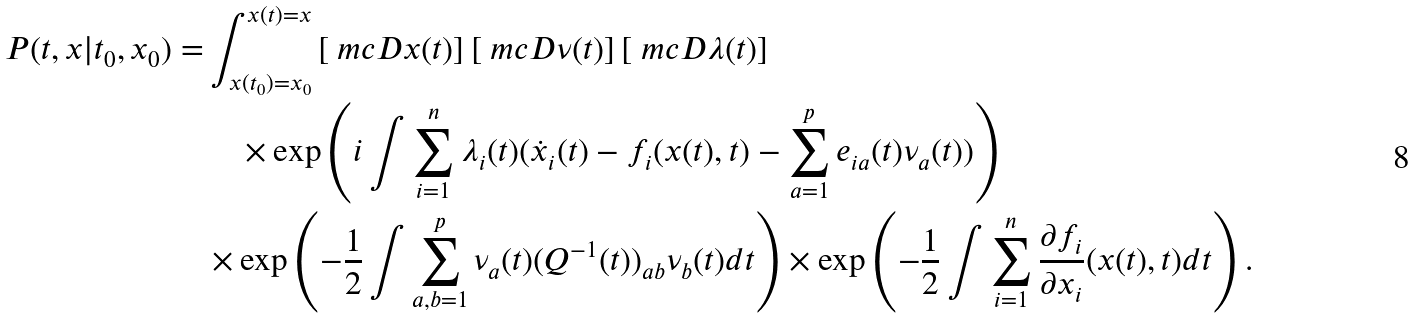<formula> <loc_0><loc_0><loc_500><loc_500>P ( t , x | t _ { 0 } , x _ { 0 } ) = & \int _ { x ( t _ { 0 } ) = x _ { 0 } } ^ { x ( t ) = x } \left [ \ m c { D } x ( t ) \right ] \left [ \ m c { D } \nu ( t ) \right ] \left [ \ m c { D } \lambda ( t ) \right ] \\ & \quad \times \exp \left ( i \int \sum _ { i = 1 } ^ { n } \lambda _ { i } ( t ) ( \dot { x } _ { i } ( t ) - f _ { i } ( x ( t ) , t ) - \sum _ { a = 1 } ^ { p } e _ { i a } ( t ) \nu _ { a } ( t ) ) \right ) \\ & \times \exp \left ( - \frac { 1 } { 2 } \int \sum _ { a , b = 1 } ^ { p } \nu _ { a } ( t ) ( Q ^ { - 1 } ( t ) ) _ { a b } \nu _ { b } ( t ) d t \right ) \times \exp \left ( - \frac { 1 } { 2 } \int \sum _ { i = 1 } ^ { n } \frac { \partial f _ { i } } { \partial x _ { i } } ( x ( t ) , t ) d t \right ) .</formula> 